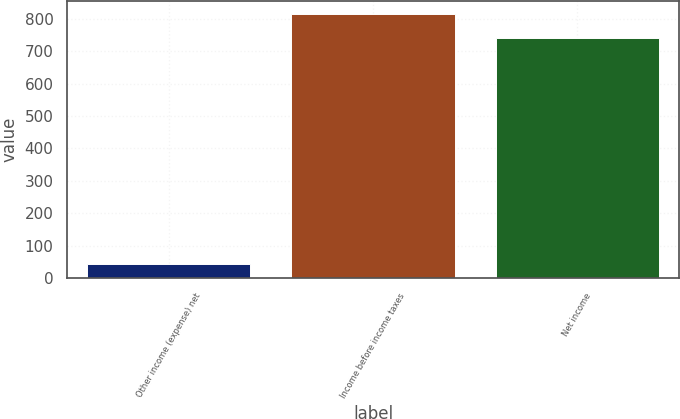<chart> <loc_0><loc_0><loc_500><loc_500><bar_chart><fcel>Other income (expense) net<fcel>Income before income taxes<fcel>Net income<nl><fcel>44<fcel>813.2<fcel>741<nl></chart> 